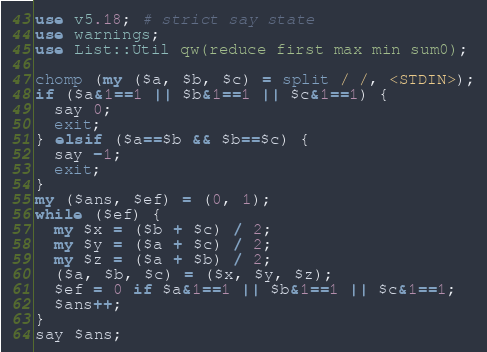<code> <loc_0><loc_0><loc_500><loc_500><_Perl_>use v5.18; # strict say state
use warnings;
use List::Util qw(reduce first max min sum0);

chomp (my ($a, $b, $c) = split / /, <STDIN>);
if ($a&1==1 || $b&1==1 || $c&1==1) {
  say 0;
  exit;
} elsif ($a==$b && $b==$c) {
  say -1;
  exit;
}
my ($ans, $ef) = (0, 1);
while ($ef) {
  my $x = ($b + $c) / 2;
  my $y = ($a + $c) / 2;
  my $z = ($a + $b) / 2;
  ($a, $b, $c) = ($x, $y, $z);
  $ef = 0 if $a&1==1 || $b&1==1 || $c&1==1;
  $ans++;
}
say $ans;</code> 